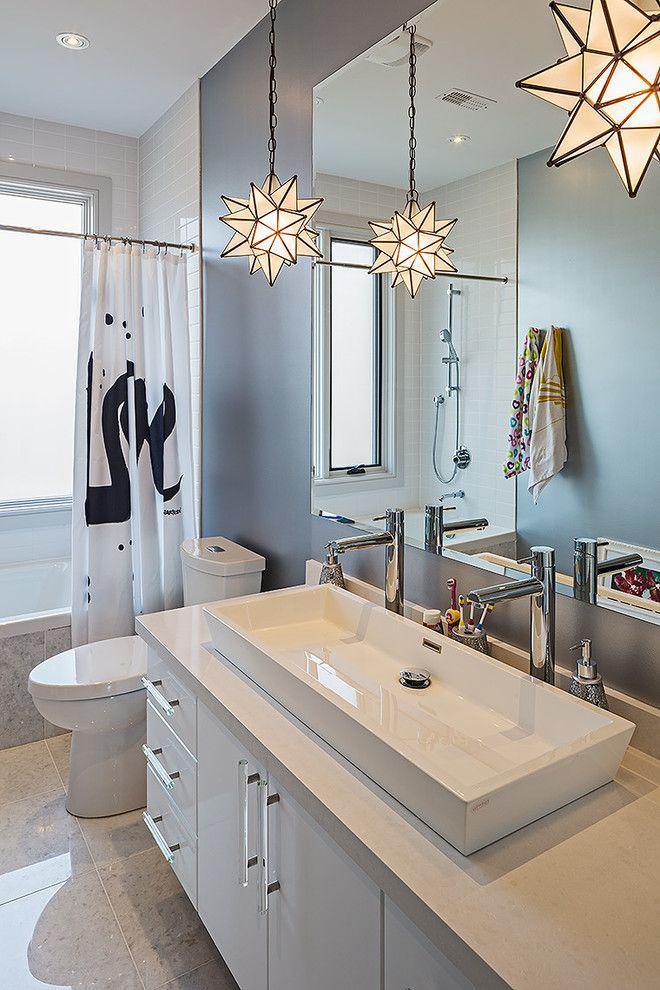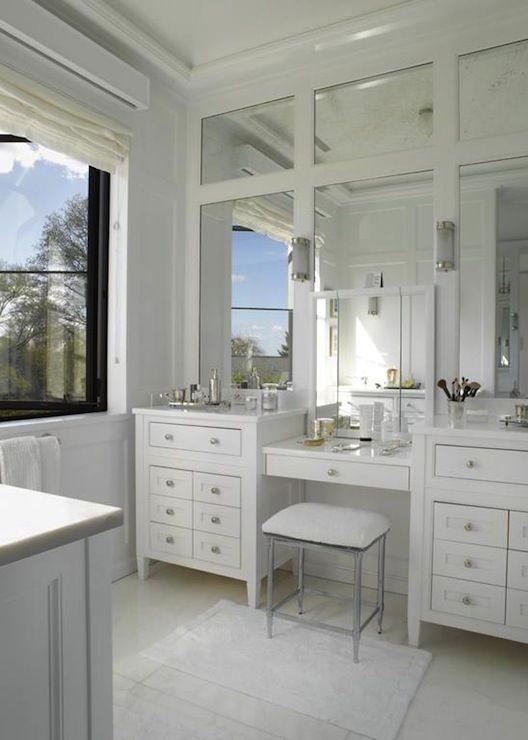The first image is the image on the left, the second image is the image on the right. Examine the images to the left and right. Is the description "One image shows a seamless mirror over an undivided white 'trough' sink with multiple spouts over it, which has a white toilet with a tank behind it." accurate? Answer yes or no. Yes. 